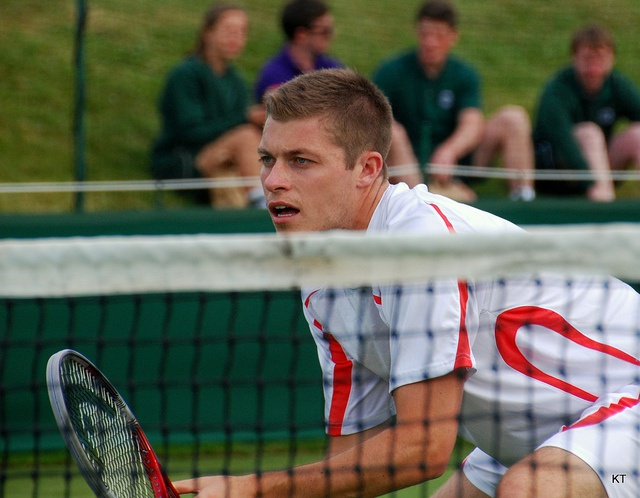Describe the objects in this image and their specific colors. I can see people in darkgreen, lavender, brown, darkgray, and gray tones, people in darkgreen, black, and gray tones, people in darkgreen, black, brown, and maroon tones, people in darkgreen, black, maroon, gray, and brown tones, and tennis racket in darkgreen, black, gray, and darkgray tones in this image. 